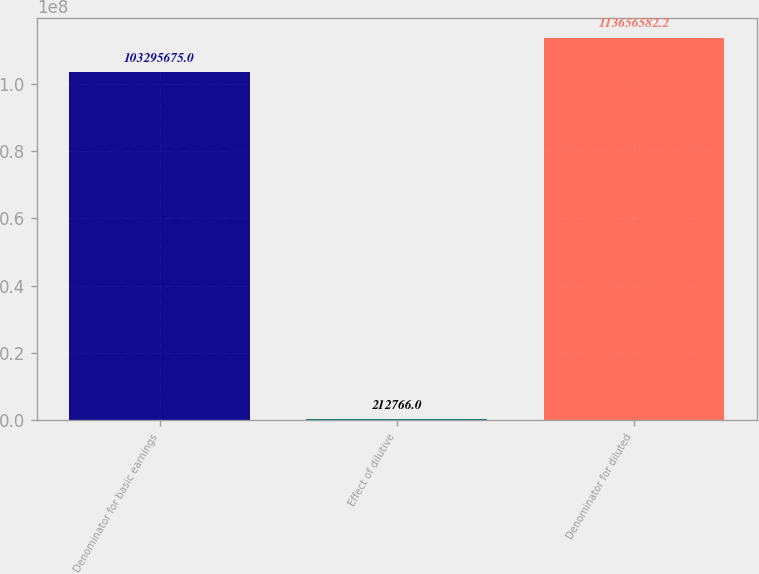Convert chart. <chart><loc_0><loc_0><loc_500><loc_500><bar_chart><fcel>Denominator for basic earnings<fcel>Effect of dilutive<fcel>Denominator for diluted<nl><fcel>1.03296e+08<fcel>212766<fcel>1.13657e+08<nl></chart> 